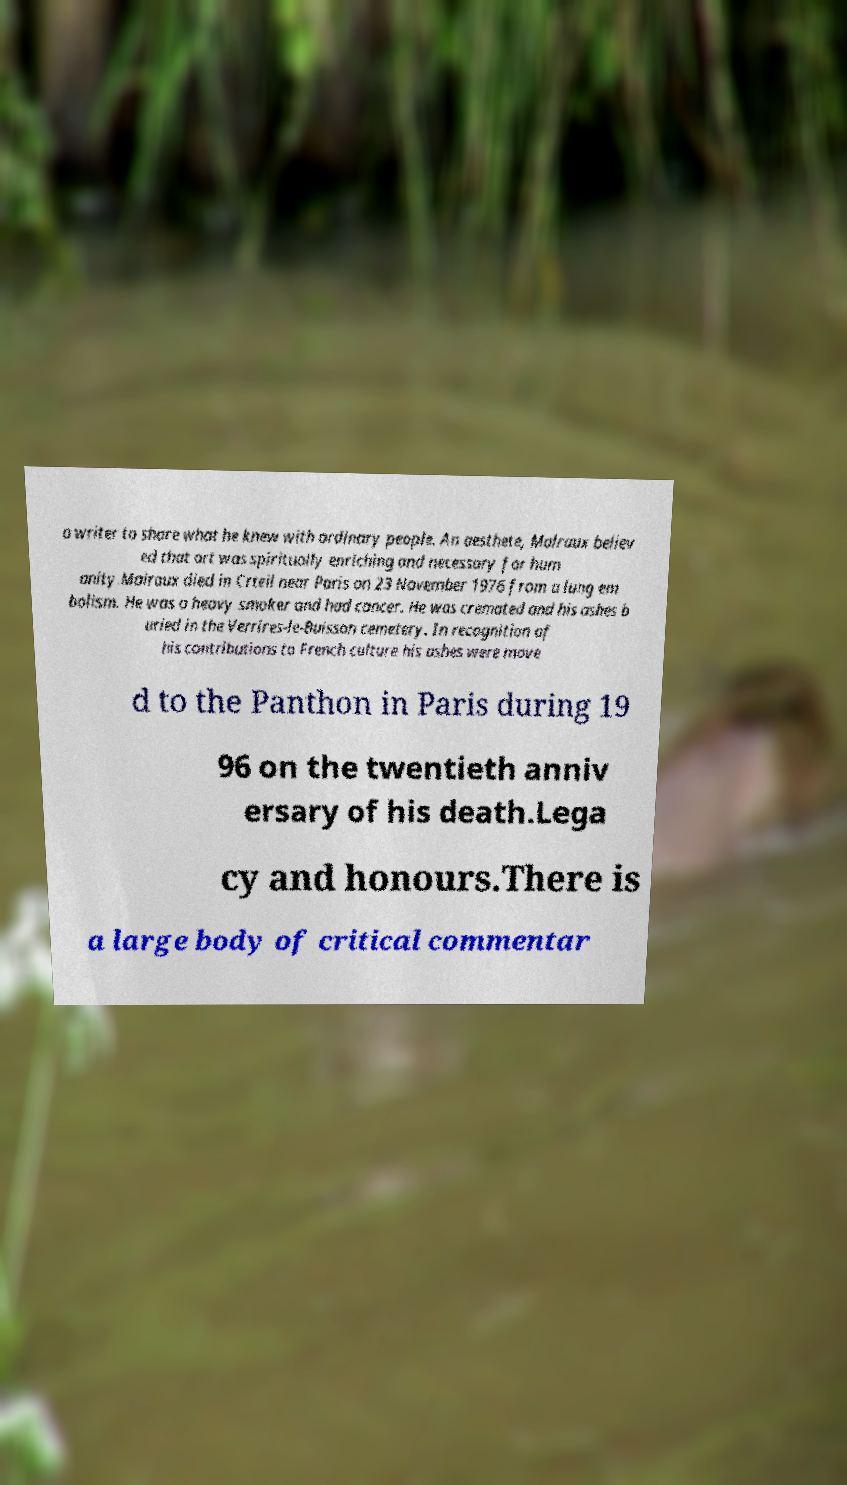There's text embedded in this image that I need extracted. Can you transcribe it verbatim? a writer to share what he knew with ordinary people. An aesthete, Malraux believ ed that art was spiritually enriching and necessary for hum anity.Malraux died in Crteil near Paris on 23 November 1976 from a lung em bolism. He was a heavy smoker and had cancer. He was cremated and his ashes b uried in the Verrires-le-Buisson cemetery. In recognition of his contributions to French culture his ashes were move d to the Panthon in Paris during 19 96 on the twentieth anniv ersary of his death.Lega cy and honours.There is a large body of critical commentar 